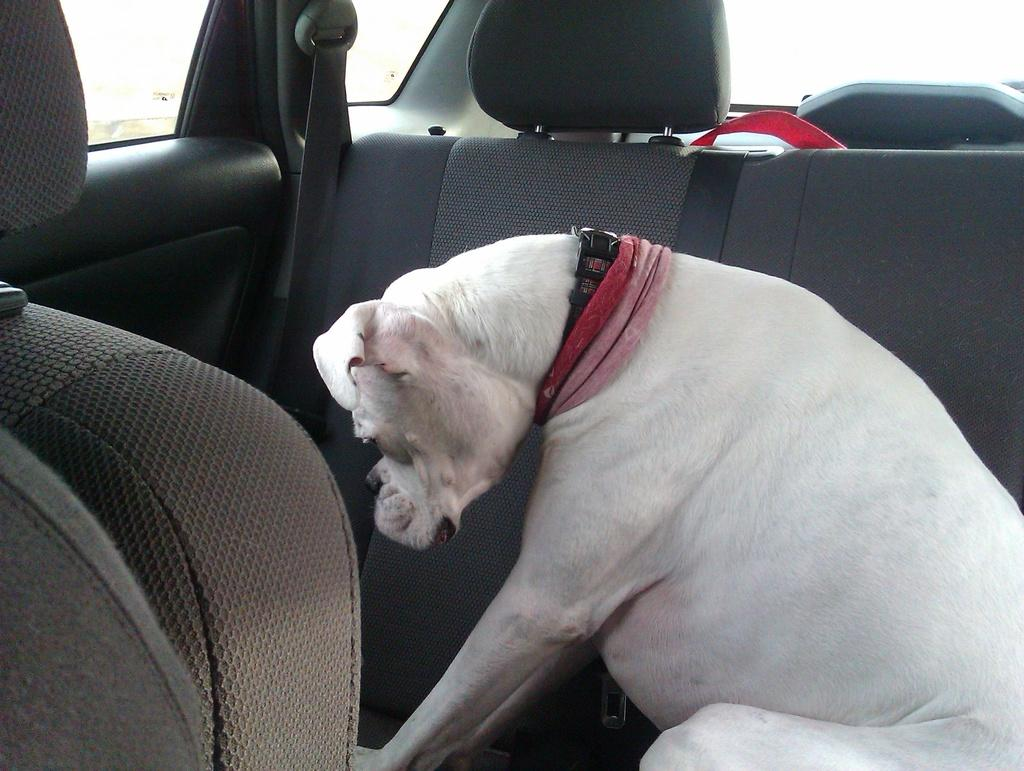What type of animal is present in the image? There is a dog in the image. What is the dog doing in the image? The dog is sitting. Where is the dog located in the image? The dog is inside a car. What type of stocking is the dog wearing in the image? There is no stocking present on the dog in the image. What type of wash is being used to clean the glass in the image? There is no glass or wash activity present in the image. 